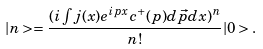<formula> <loc_0><loc_0><loc_500><loc_500>| n > = \frac { ( i \int j ( x ) e ^ { i p x } c ^ { + } ( p ) d \vec { p } d x ) ^ { n } } { n ! } | 0 > .</formula> 